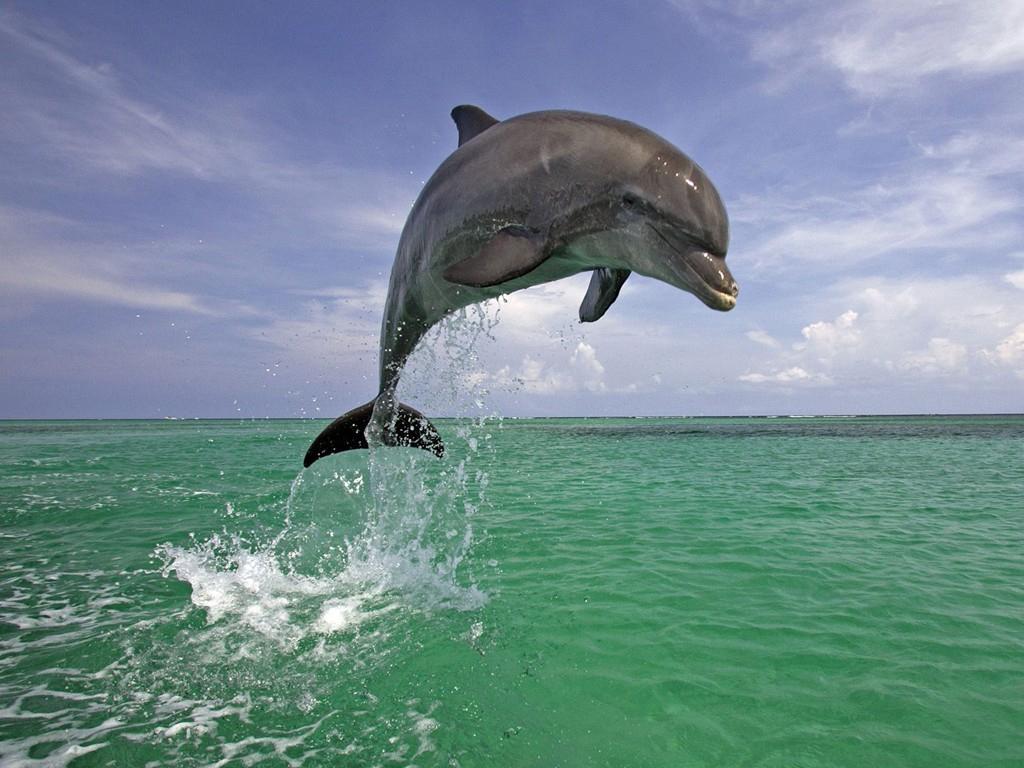How would you summarize this image in a sentence or two? In this picture we can see the sky and water. This picture is mainly highlighted with a dolphin in the air. 